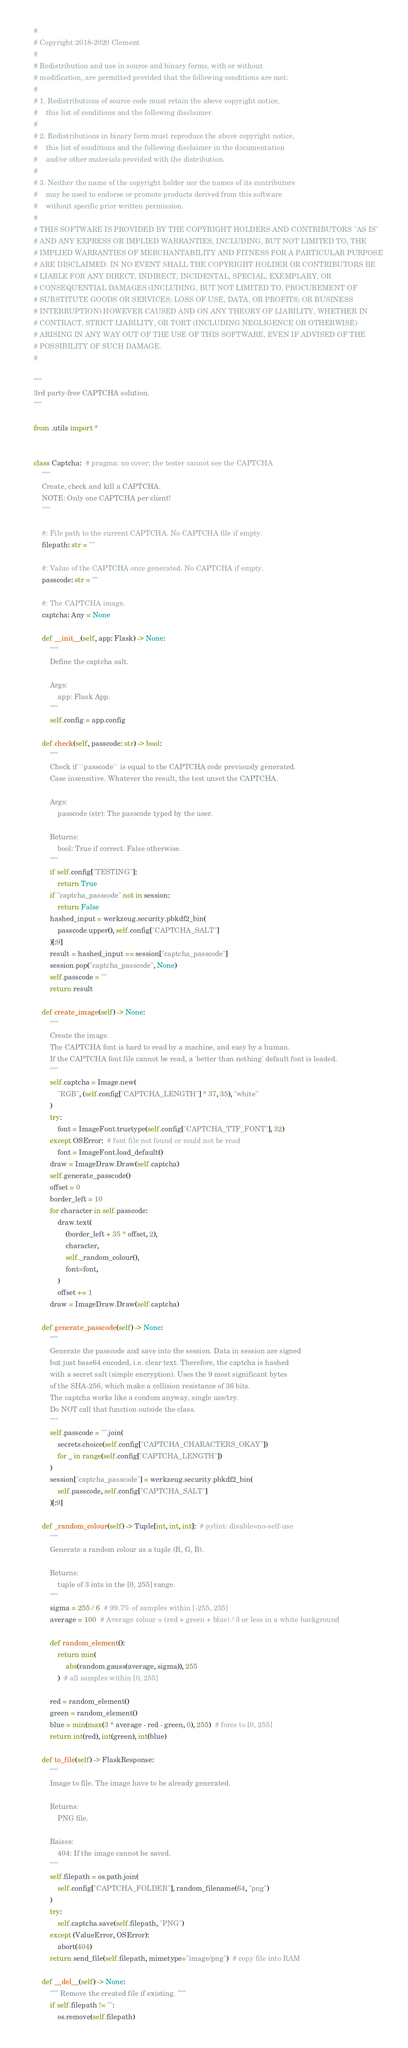Convert code to text. <code><loc_0><loc_0><loc_500><loc_500><_Python_>#
# Copyright 2018-2020 Clement
#
# Redistribution and use in source and binary forms, with or without
# modification, are permitted provided that the following conditions are met:
#
# 1. Redistributions of source code must retain the above copyright notice,
#    this list of conditions and the following disclaimer.
#
# 2. Redistributions in binary form must reproduce the above copyright notice,
#    this list of conditions and the following disclaimer in the documentation
#    and/or other materials provided with the distribution.
#
# 3. Neither the name of the copyright holder nor the names of its contributors
#    may be used to endorse or promote products derived from this software
#    without specific prior written permission.
#
# THIS SOFTWARE IS PROVIDED BY THE COPYRIGHT HOLDERS AND CONTRIBUTORS "AS IS"
# AND ANY EXPRESS OR IMPLIED WARRANTIES, INCLUDING, BUT NOT LIMITED TO, THE
# IMPLIED WARRANTIES OF MERCHANTABILITY AND FITNESS FOR A PARTICULAR PURPOSE
# ARE DISCLAIMED. IN NO EVENT SHALL THE COPYRIGHT HOLDER OR CONTRIBUTORS BE
# LIABLE FOR ANY DIRECT, INDIRECT, INCIDENTAL, SPECIAL, EXEMPLARY, OR
# CONSEQUENTIAL DAMAGES (INCLUDING, BUT NOT LIMITED TO, PROCUREMENT OF
# SUBSTITUTE GOODS OR SERVICES; LOSS OF USE, DATA, OR PROFITS; OR BUSINESS
# INTERRUPTION) HOWEVER CAUSED AND ON ANY THEORY OF LIABILITY, WHETHER IN
# CONTRACT, STRICT LIABILITY, OR TORT (INCLUDING NEGLIGENCE OR OTHERWISE)
# ARISING IN ANY WAY OUT OF THE USE OF THIS SOFTWARE, EVEN IF ADVISED OF THE
# POSSIBILITY OF SUCH DAMAGE.
#

"""
3rd party-free CAPTCHA solution.
"""

from .utils import *


class Captcha:  # pragma: no cover; the tester cannot see the CAPTCHA
    """
    Create, check and kill a CAPTCHA.
    NOTE: Only one CAPTCHA per client!
    """

    #: File path to the current CAPTCHA. No CAPTCHA file if empty.
    filepath: str = ""

    #: Value of the CAPTCHA once generated. No CAPTCHA if empty.
    passcode: str = ""

    #: The CAPTCHA image.
    captcha: Any = None

    def __init__(self, app: Flask) -> None:
        """
        Define the captcha salt.

        Args:
            app: Flask App.
        """
        self.config = app.config

    def check(self, passcode: str) -> bool:
        """
        Check if ``passcode`` is equal to the CAPTCHA code previously generated.
        Case insensitive. Whatever the result, the test unset the CAPTCHA.

        Args:
            passcode (str): The passcode typed by the user.

        Returns:
            bool: True if correct. False otherwise.
        """
        if self.config["TESTING"]:
            return True
        if "captcha_passcode" not in session:
            return False
        hashed_input = werkzeug.security.pbkdf2_bin(
            passcode.upper(), self.config["CAPTCHA_SALT"]
        )[:9]
        result = hashed_input == session["captcha_passcode"]
        session.pop("captcha_passcode", None)
        self.passcode = ""
        return result

    def create_image(self) -> None:
        """
        Create the image.
        The CAPTCHA font is hard to read by a machine, and easy by a human.
        If the CAPTCHA font file cannot be read, a 'better than nothing' default font is loaded.
        """
        self.captcha = Image.new(
            "RGB", (self.config["CAPTCHA_LENGTH"] * 37, 35), "white"
        )
        try:
            font = ImageFont.truetype(self.config["CAPTCHA_TTF_FONT"], 32)
        except OSError:  # font file not found or could not be read
            font = ImageFont.load_default()
        draw = ImageDraw.Draw(self.captcha)
        self.generate_passcode()
        offset = 0
        border_left = 10
        for character in self.passcode:
            draw.text(
                (border_left + 35 * offset, 2),
                character,
                self._random_colour(),
                font=font,
            )
            offset += 1
        draw = ImageDraw.Draw(self.captcha)

    def generate_passcode(self) -> None:
        """
        Generate the passcode and save into the session. Data in session are signed
        but just base64 encoded, i.e. clear text. Therefore, the captcha is hashed
        with a secret salt (simple encryption). Uses the 9 most significant bytes
        of the SHA-256, which make a collision resistance of 36 bits.
        The captcha works like a condom anyway, single use/try.
        Do NOT call that function outside the class.
        """
        self.passcode = "".join(
            secrets.choice(self.config["CAPTCHA_CHARACTERS_OKAY"])
            for _ in range(self.config["CAPTCHA_LENGTH"])
        )
        session["captcha_passcode"] = werkzeug.security.pbkdf2_bin(
            self.passcode, self.config["CAPTCHA_SALT"]
        )[:9]

    def _random_colour(self) -> Tuple[int, int, int]:  # pylint: disable=no-self-use
        """
        Generate a random colour as a tuple (R, G, B).

        Returns:
            tuple of 3 ints in the [0, 255] range.
        """
        sigma = 255 / 6  # 99.7% of samples within [-255, 255]
        average = 100  # Average colour = (red + green + blue) / 3 or less in a white background

        def random_element():
            return min(
                abs(random.gauss(average, sigma)), 255
            )  # all samples within [0, 255]

        red = random_element()
        green = random_element()
        blue = min(max(3 * average - red - green, 0), 255)  # force to [0, 255]
        return int(red), int(green), int(blue)

    def to_file(self) -> FlaskResponse:
        """
        Image to file. The image have to be already generated.

        Returns:
            PNG file.

        Raises:
            404: If the image cannot be saved.
        """
        self.filepath = os.path.join(
            self.config["CAPTCHA_FOLDER"], random_filename(64, "png")
        )
        try:
            self.captcha.save(self.filepath, "PNG")
        except (ValueError, OSError):
            abort(404)
        return send_file(self.filepath, mimetype="image/png")  # copy file into RAM

    def __del__(self) -> None:
        """ Remove the created file if existing. """
        if self.filepath != "":
            os.remove(self.filepath)
</code> 